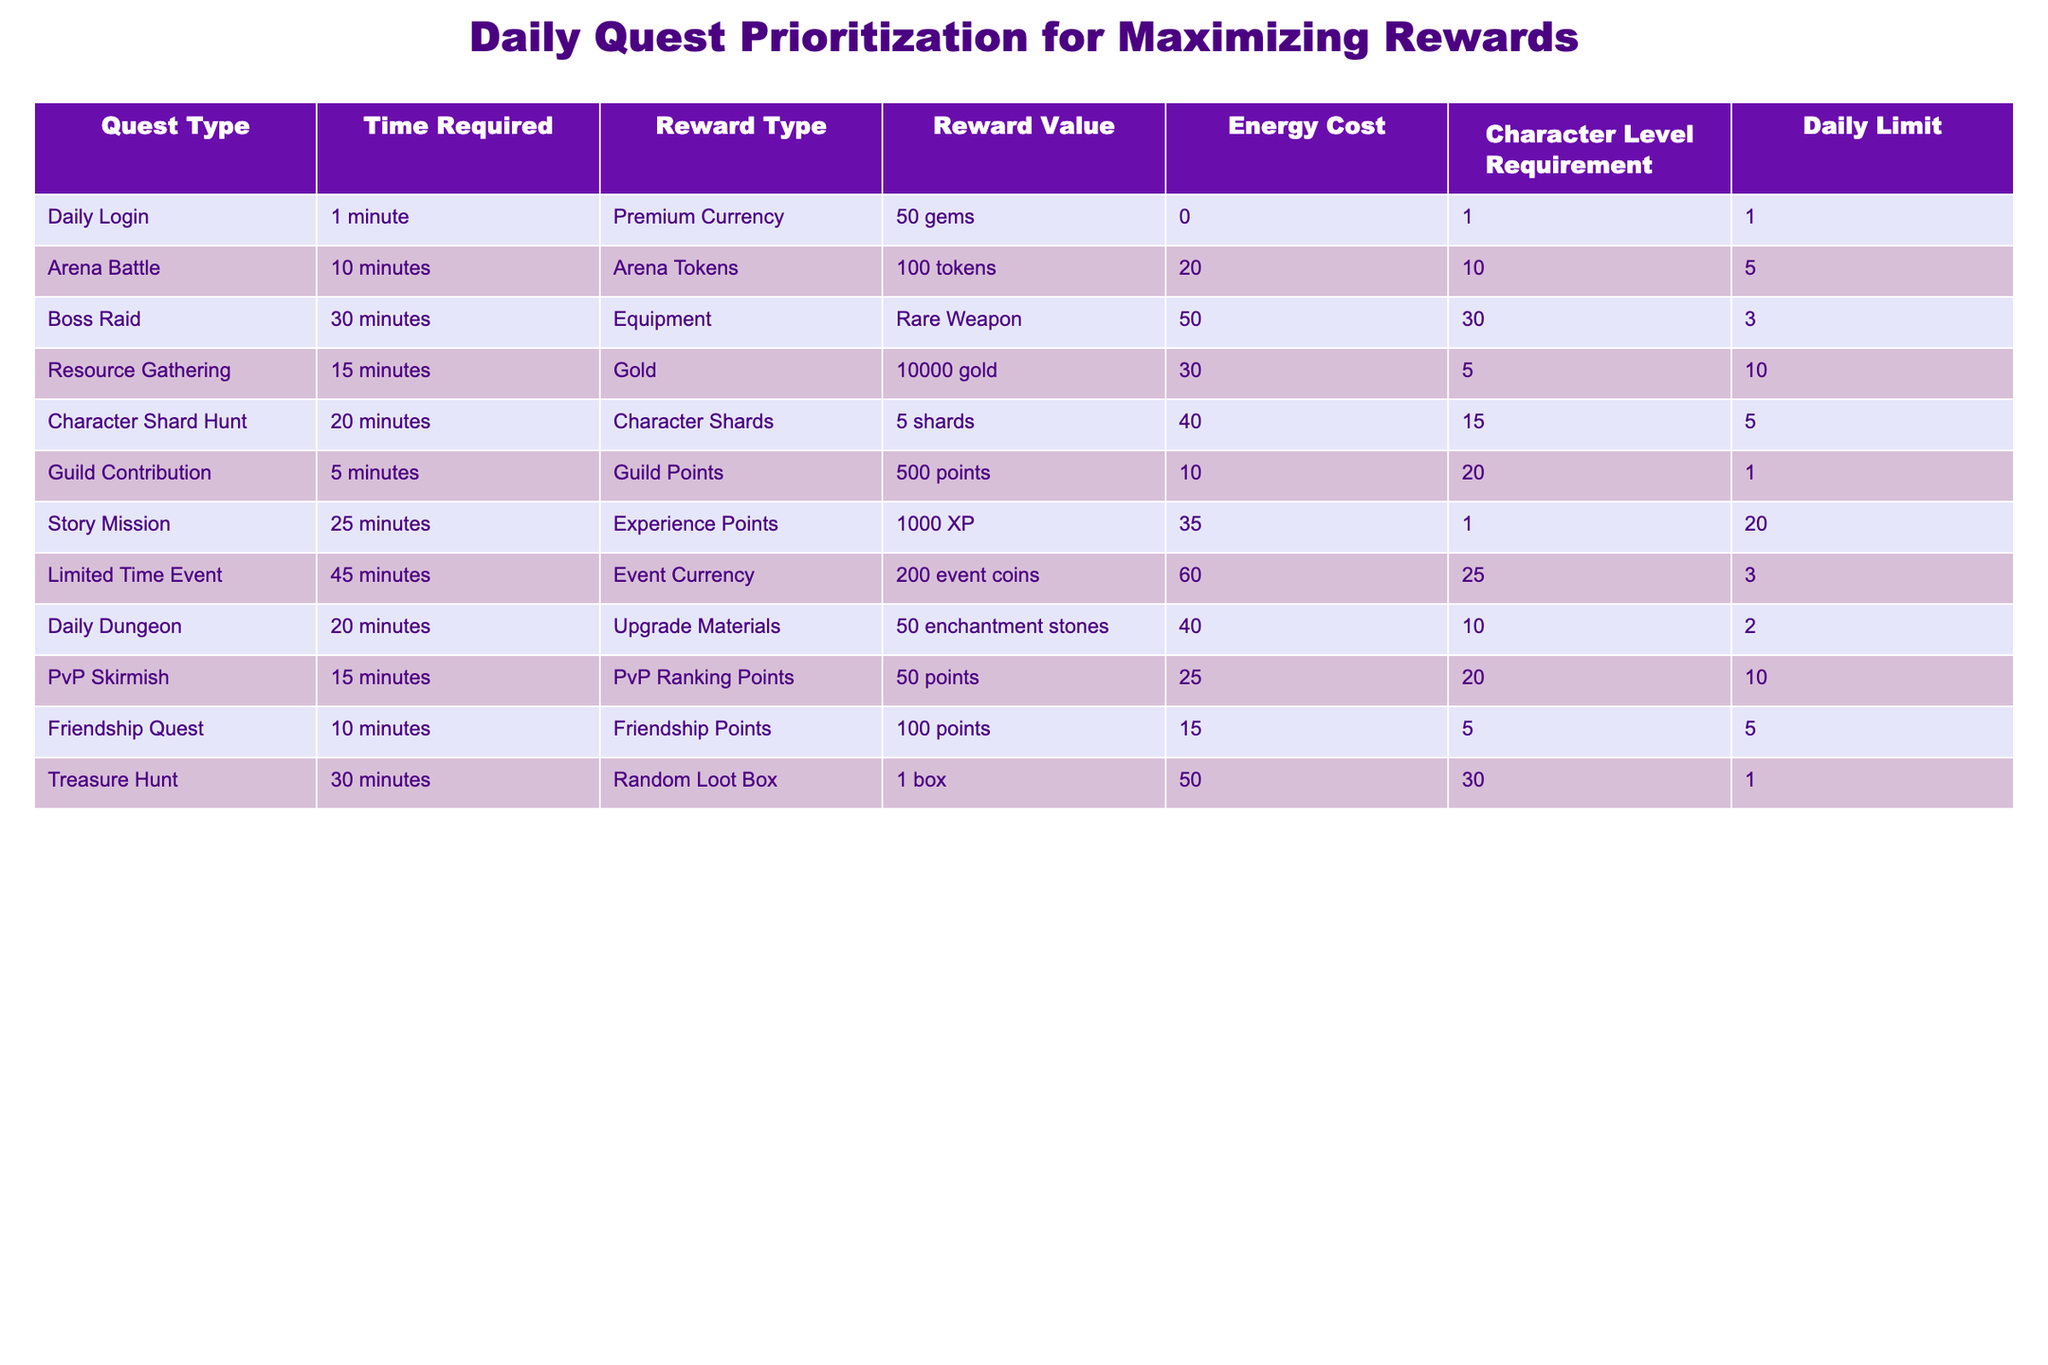What is the highest reward type available in the daily quests? By checking the "Reward Type" column, we see the quest with the highest reward based on the "Reward Value" which is the "Rare Weapon" from the "Boss Raid" quest.
Answer: Rare Weapon How many total energy points are needed for all Arena Battles? The energy cost for one Arena Battle is 20 points. With a daily limit of 5, the total energy needed is 20 * 5 = 100 points.
Answer: 100 Which quest has the shortest time requirement and what's its reward type? The "Daily Login" quest requires only 1 minute, and its reward type is "Premium Currency".
Answer: Premium Currency Is it possible to complete all three "Boss Raid" quests in one day? Each "Boss Raid" quest has a daily limit of 3, which means you can complete the maximum allowed. So yes, it's possible.
Answer: Yes What is the total time required to complete all daily quests at their limits? To find this, we sum the time required for each quest multiplied by their daily limits: (1*1) + (10*5) + (30*3) + (15*10) + (20*5) + (5*1) + (25*20) + (45*3) + (20*2) + (15*10) = 1 + 50 + 90 + 150 + 100 + 5 + 500 + 135 + 40 + 150 = 1171 minutes.
Answer: 1171 minutes Which quest provides the most character shards for the least energy cost? By comparing the reward value and energy cost, the "Character Shard Hunt" offers 5 character shards for 40 energy points, making it less efficient than other quests. However, comparing quests indicates a better option is lacking energy efficiency but still offers good rewards.
Answer: Character Shard Hunt 